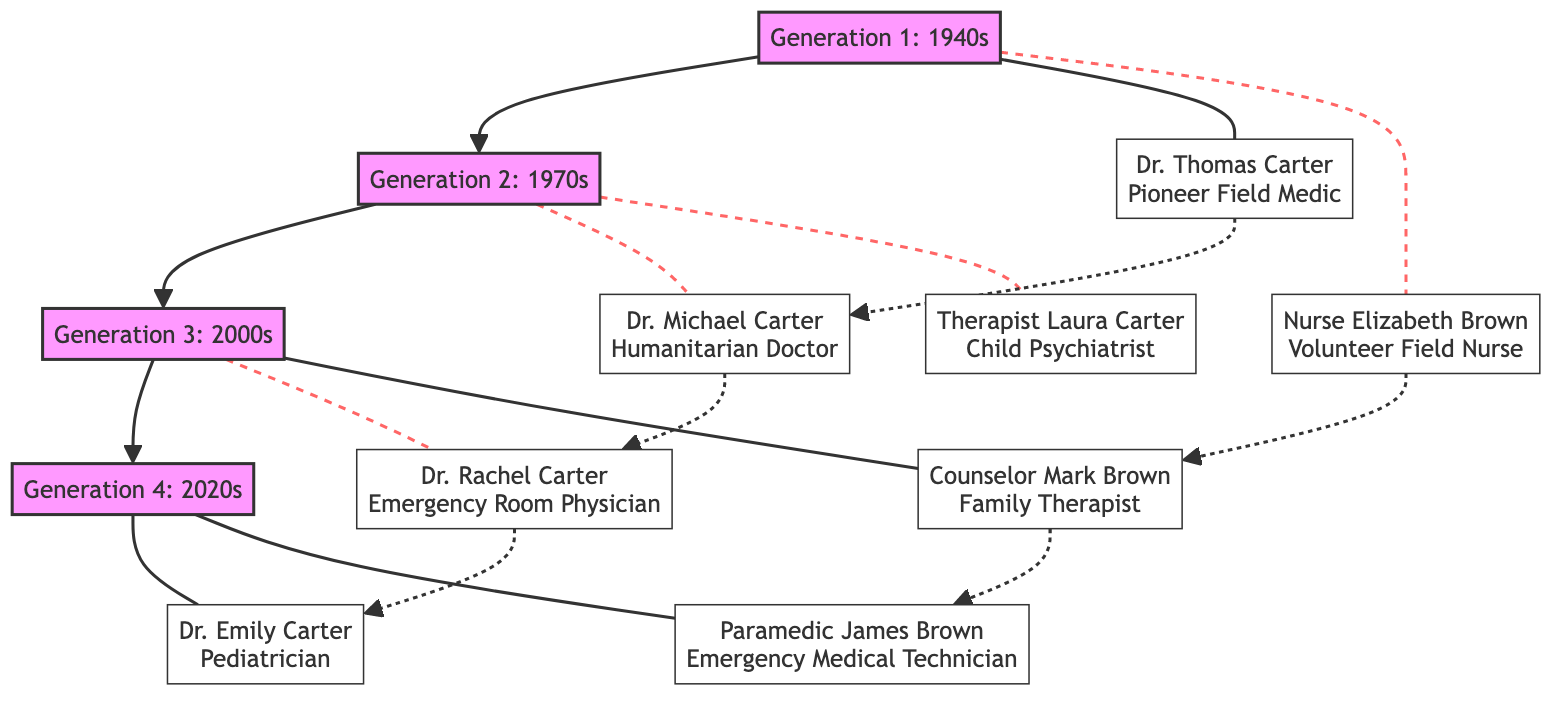What is the role of Dr. Thomas Carter? The diagram indicates that Dr. Thomas Carter is a "Pioneer Field Medic." This information can be found directly under his name in the Generation 1 section.
Answer: Pioneer Field Medic How many generations are represented in the diagram? The diagram visually displays four generations, numbered Generation 1 through Generation 4. This can be counted in the "generations" section of the diagram.
Answer: 4 Which individual focused on trauma-informed care for children? Referring to the diagram, "Therapist Laura Carter" is identified as specializing in mental health care for children in post-war areas, which underlines her focus on trauma-informed care.
Answer: Therapist Laura Carter Who contributed by introducing family letters? The diagram points out that "Nurse Elizabeth Brown" introduced family letters to boost patient morale, which is noted in her key contributions under Generation 1.
Answer: Nurse Elizabeth Brown Which generations show a direct link to Dr. Rachel Carter? By examining the connections in the diagram, Dr. Rachel Carter is linked to Generation 2 through Dr. Michael Carter, who is his father. Additionally, Dr. Rachel is in Generation 3.
Answer: Generation 2 What key contribution did Dr. Michael Carter make? The diagram specifies that Dr. Michael Carter enhanced training on compassionate care in conflict zones, specifying his key contribution to the field in Generation 2.
Answer: Enhanced training on compassionate care Which role does James Brown hold? According to the diagram, "Paramedic James Brown" is labeled as an "Emergency Medical Technician," providing a straightforward identification of his role within Generation 4.
Answer: Emergency Medical Technician How is compassionate care integrated according to Dr. Rachel Carter? Examining the diagram reveals that Dr. Rachel Carter integrated compassionate care techniques into emergency medicine, which is detailed in her description.
Answer: Integrated compassionate care techniques into emergency medicine Which contribution is linked to family therapy? The diagram notes that "Counselor Mark Brown" introduced family-centric therapy models in hospitals, linking him to the concept of family therapy in Generation 3.
Answer: Introduced family-centric therapy models in hospitals 